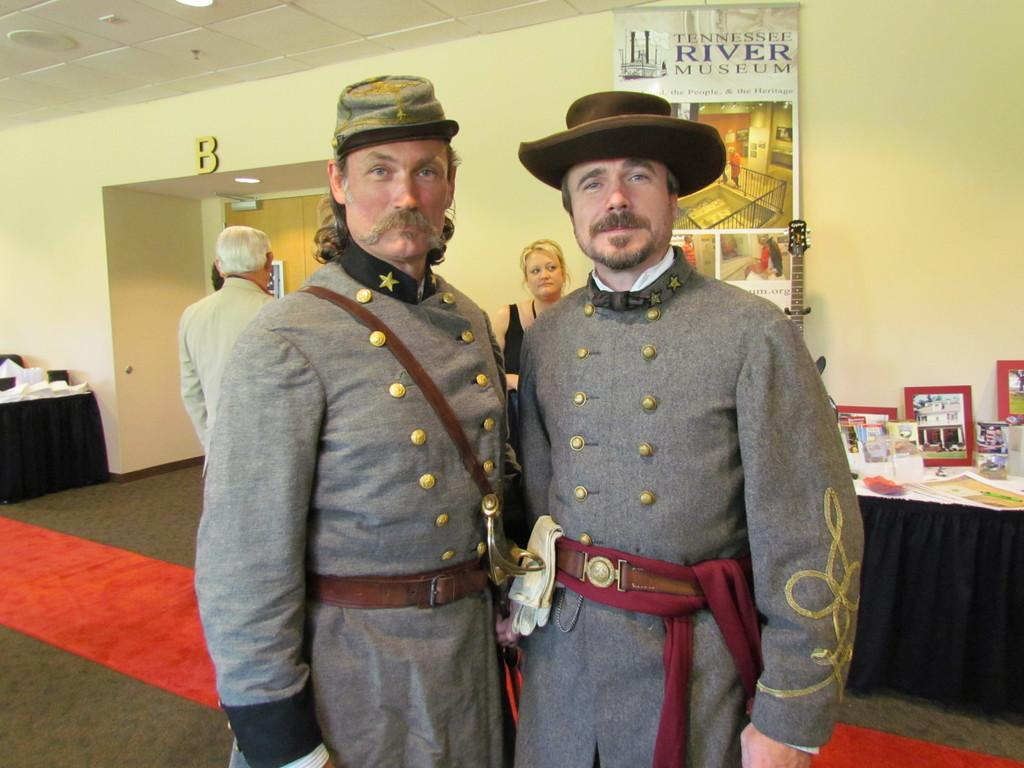How many people are visible in the image? There are two persons standing in the image. Are there any other people in the image besides the two standing? Yes, there are two more persons in the background of the image. What can be seen on the right side of the image? There is a table on the right side of the image. What type of tin can be seen on the table in the image? There is no tin present on the table in the image. Can you describe the bottle that is being used by one of the persons in the image? There is no bottle visible in the image; only the people and the table are present. 